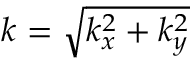<formula> <loc_0><loc_0><loc_500><loc_500>k = \sqrt { k _ { x } ^ { 2 } + k _ { y } ^ { 2 } }</formula> 